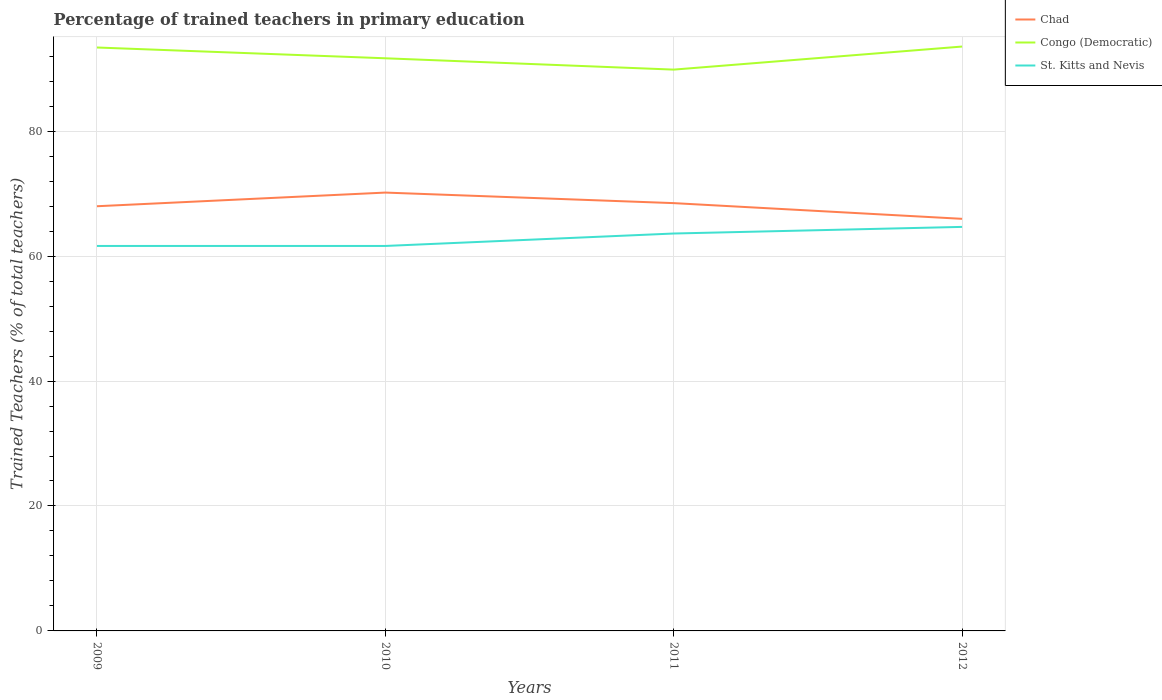How many different coloured lines are there?
Provide a short and direct response. 3. Is the number of lines equal to the number of legend labels?
Make the answer very short. Yes. Across all years, what is the maximum percentage of trained teachers in St. Kitts and Nevis?
Offer a very short reply. 61.63. In which year was the percentage of trained teachers in Chad maximum?
Make the answer very short. 2012. What is the total percentage of trained teachers in Congo (Democratic) in the graph?
Ensure brevity in your answer.  -1.88. What is the difference between the highest and the second highest percentage of trained teachers in Congo (Democratic)?
Your response must be concise. 3.69. Is the percentage of trained teachers in Congo (Democratic) strictly greater than the percentage of trained teachers in St. Kitts and Nevis over the years?
Offer a terse response. No. How many lines are there?
Give a very brief answer. 3. How many years are there in the graph?
Ensure brevity in your answer.  4. What is the difference between two consecutive major ticks on the Y-axis?
Keep it short and to the point. 20. Does the graph contain any zero values?
Offer a terse response. No. Does the graph contain grids?
Offer a very short reply. Yes. How many legend labels are there?
Offer a terse response. 3. How are the legend labels stacked?
Your answer should be compact. Vertical. What is the title of the graph?
Provide a short and direct response. Percentage of trained teachers in primary education. Does "Latvia" appear as one of the legend labels in the graph?
Provide a short and direct response. No. What is the label or title of the X-axis?
Provide a succinct answer. Years. What is the label or title of the Y-axis?
Offer a very short reply. Trained Teachers (% of total teachers). What is the Trained Teachers (% of total teachers) of Chad in 2009?
Your answer should be very brief. 67.98. What is the Trained Teachers (% of total teachers) in Congo (Democratic) in 2009?
Offer a very short reply. 93.39. What is the Trained Teachers (% of total teachers) in St. Kitts and Nevis in 2009?
Your response must be concise. 61.63. What is the Trained Teachers (% of total teachers) in Chad in 2010?
Make the answer very short. 70.17. What is the Trained Teachers (% of total teachers) in Congo (Democratic) in 2010?
Ensure brevity in your answer.  91.67. What is the Trained Teachers (% of total teachers) of St. Kitts and Nevis in 2010?
Your answer should be very brief. 61.63. What is the Trained Teachers (% of total teachers) in Chad in 2011?
Keep it short and to the point. 68.48. What is the Trained Teachers (% of total teachers) in Congo (Democratic) in 2011?
Your response must be concise. 89.85. What is the Trained Teachers (% of total teachers) in St. Kitts and Nevis in 2011?
Provide a succinct answer. 63.62. What is the Trained Teachers (% of total teachers) of Chad in 2012?
Give a very brief answer. 65.97. What is the Trained Teachers (% of total teachers) of Congo (Democratic) in 2012?
Offer a very short reply. 93.55. What is the Trained Teachers (% of total teachers) in St. Kitts and Nevis in 2012?
Give a very brief answer. 64.68. Across all years, what is the maximum Trained Teachers (% of total teachers) in Chad?
Offer a very short reply. 70.17. Across all years, what is the maximum Trained Teachers (% of total teachers) in Congo (Democratic)?
Offer a terse response. 93.55. Across all years, what is the maximum Trained Teachers (% of total teachers) of St. Kitts and Nevis?
Provide a succinct answer. 64.68. Across all years, what is the minimum Trained Teachers (% of total teachers) of Chad?
Provide a succinct answer. 65.97. Across all years, what is the minimum Trained Teachers (% of total teachers) in Congo (Democratic)?
Offer a terse response. 89.85. Across all years, what is the minimum Trained Teachers (% of total teachers) in St. Kitts and Nevis?
Offer a terse response. 61.63. What is the total Trained Teachers (% of total teachers) of Chad in the graph?
Your answer should be compact. 272.6. What is the total Trained Teachers (% of total teachers) in Congo (Democratic) in the graph?
Offer a terse response. 368.46. What is the total Trained Teachers (% of total teachers) in St. Kitts and Nevis in the graph?
Provide a short and direct response. 251.54. What is the difference between the Trained Teachers (% of total teachers) of Chad in 2009 and that in 2010?
Provide a succinct answer. -2.19. What is the difference between the Trained Teachers (% of total teachers) of Congo (Democratic) in 2009 and that in 2010?
Your answer should be compact. 1.73. What is the difference between the Trained Teachers (% of total teachers) of St. Kitts and Nevis in 2009 and that in 2010?
Offer a very short reply. 0. What is the difference between the Trained Teachers (% of total teachers) in Chad in 2009 and that in 2011?
Your answer should be compact. -0.5. What is the difference between the Trained Teachers (% of total teachers) of Congo (Democratic) in 2009 and that in 2011?
Your response must be concise. 3.54. What is the difference between the Trained Teachers (% of total teachers) of St. Kitts and Nevis in 2009 and that in 2011?
Offer a very short reply. -1.99. What is the difference between the Trained Teachers (% of total teachers) in Chad in 2009 and that in 2012?
Your response must be concise. 2.02. What is the difference between the Trained Teachers (% of total teachers) in Congo (Democratic) in 2009 and that in 2012?
Your answer should be very brief. -0.15. What is the difference between the Trained Teachers (% of total teachers) in St. Kitts and Nevis in 2009 and that in 2012?
Your answer should be compact. -3.05. What is the difference between the Trained Teachers (% of total teachers) in Chad in 2010 and that in 2011?
Offer a terse response. 1.69. What is the difference between the Trained Teachers (% of total teachers) of Congo (Democratic) in 2010 and that in 2011?
Your response must be concise. 1.81. What is the difference between the Trained Teachers (% of total teachers) of St. Kitts and Nevis in 2010 and that in 2011?
Your answer should be compact. -1.99. What is the difference between the Trained Teachers (% of total teachers) of Chad in 2010 and that in 2012?
Offer a terse response. 4.2. What is the difference between the Trained Teachers (% of total teachers) in Congo (Democratic) in 2010 and that in 2012?
Offer a terse response. -1.88. What is the difference between the Trained Teachers (% of total teachers) of St. Kitts and Nevis in 2010 and that in 2012?
Your answer should be very brief. -3.05. What is the difference between the Trained Teachers (% of total teachers) in Chad in 2011 and that in 2012?
Your response must be concise. 2.51. What is the difference between the Trained Teachers (% of total teachers) of Congo (Democratic) in 2011 and that in 2012?
Keep it short and to the point. -3.69. What is the difference between the Trained Teachers (% of total teachers) in St. Kitts and Nevis in 2011 and that in 2012?
Your answer should be compact. -1.06. What is the difference between the Trained Teachers (% of total teachers) in Chad in 2009 and the Trained Teachers (% of total teachers) in Congo (Democratic) in 2010?
Your answer should be compact. -23.69. What is the difference between the Trained Teachers (% of total teachers) in Chad in 2009 and the Trained Teachers (% of total teachers) in St. Kitts and Nevis in 2010?
Offer a terse response. 6.36. What is the difference between the Trained Teachers (% of total teachers) of Congo (Democratic) in 2009 and the Trained Teachers (% of total teachers) of St. Kitts and Nevis in 2010?
Your response must be concise. 31.77. What is the difference between the Trained Teachers (% of total teachers) in Chad in 2009 and the Trained Teachers (% of total teachers) in Congo (Democratic) in 2011?
Your response must be concise. -21.87. What is the difference between the Trained Teachers (% of total teachers) of Chad in 2009 and the Trained Teachers (% of total teachers) of St. Kitts and Nevis in 2011?
Offer a very short reply. 4.37. What is the difference between the Trained Teachers (% of total teachers) in Congo (Democratic) in 2009 and the Trained Teachers (% of total teachers) in St. Kitts and Nevis in 2011?
Ensure brevity in your answer.  29.78. What is the difference between the Trained Teachers (% of total teachers) of Chad in 2009 and the Trained Teachers (% of total teachers) of Congo (Democratic) in 2012?
Offer a very short reply. -25.56. What is the difference between the Trained Teachers (% of total teachers) of Chad in 2009 and the Trained Teachers (% of total teachers) of St. Kitts and Nevis in 2012?
Your response must be concise. 3.31. What is the difference between the Trained Teachers (% of total teachers) in Congo (Democratic) in 2009 and the Trained Teachers (% of total teachers) in St. Kitts and Nevis in 2012?
Your answer should be very brief. 28.72. What is the difference between the Trained Teachers (% of total teachers) of Chad in 2010 and the Trained Teachers (% of total teachers) of Congo (Democratic) in 2011?
Give a very brief answer. -19.68. What is the difference between the Trained Teachers (% of total teachers) in Chad in 2010 and the Trained Teachers (% of total teachers) in St. Kitts and Nevis in 2011?
Keep it short and to the point. 6.55. What is the difference between the Trained Teachers (% of total teachers) in Congo (Democratic) in 2010 and the Trained Teachers (% of total teachers) in St. Kitts and Nevis in 2011?
Offer a terse response. 28.05. What is the difference between the Trained Teachers (% of total teachers) of Chad in 2010 and the Trained Teachers (% of total teachers) of Congo (Democratic) in 2012?
Your answer should be compact. -23.38. What is the difference between the Trained Teachers (% of total teachers) in Chad in 2010 and the Trained Teachers (% of total teachers) in St. Kitts and Nevis in 2012?
Keep it short and to the point. 5.49. What is the difference between the Trained Teachers (% of total teachers) of Congo (Democratic) in 2010 and the Trained Teachers (% of total teachers) of St. Kitts and Nevis in 2012?
Offer a very short reply. 26.99. What is the difference between the Trained Teachers (% of total teachers) in Chad in 2011 and the Trained Teachers (% of total teachers) in Congo (Democratic) in 2012?
Your response must be concise. -25.07. What is the difference between the Trained Teachers (% of total teachers) in Chad in 2011 and the Trained Teachers (% of total teachers) in St. Kitts and Nevis in 2012?
Your answer should be compact. 3.81. What is the difference between the Trained Teachers (% of total teachers) in Congo (Democratic) in 2011 and the Trained Teachers (% of total teachers) in St. Kitts and Nevis in 2012?
Keep it short and to the point. 25.18. What is the average Trained Teachers (% of total teachers) in Chad per year?
Offer a very short reply. 68.15. What is the average Trained Teachers (% of total teachers) in Congo (Democratic) per year?
Offer a very short reply. 92.11. What is the average Trained Teachers (% of total teachers) of St. Kitts and Nevis per year?
Ensure brevity in your answer.  62.89. In the year 2009, what is the difference between the Trained Teachers (% of total teachers) of Chad and Trained Teachers (% of total teachers) of Congo (Democratic)?
Make the answer very short. -25.41. In the year 2009, what is the difference between the Trained Teachers (% of total teachers) in Chad and Trained Teachers (% of total teachers) in St. Kitts and Nevis?
Your answer should be compact. 6.36. In the year 2009, what is the difference between the Trained Teachers (% of total teachers) in Congo (Democratic) and Trained Teachers (% of total teachers) in St. Kitts and Nevis?
Make the answer very short. 31.77. In the year 2010, what is the difference between the Trained Teachers (% of total teachers) in Chad and Trained Teachers (% of total teachers) in Congo (Democratic)?
Offer a very short reply. -21.5. In the year 2010, what is the difference between the Trained Teachers (% of total teachers) of Chad and Trained Teachers (% of total teachers) of St. Kitts and Nevis?
Ensure brevity in your answer.  8.54. In the year 2010, what is the difference between the Trained Teachers (% of total teachers) of Congo (Democratic) and Trained Teachers (% of total teachers) of St. Kitts and Nevis?
Your answer should be compact. 30.04. In the year 2011, what is the difference between the Trained Teachers (% of total teachers) in Chad and Trained Teachers (% of total teachers) in Congo (Democratic)?
Keep it short and to the point. -21.37. In the year 2011, what is the difference between the Trained Teachers (% of total teachers) of Chad and Trained Teachers (% of total teachers) of St. Kitts and Nevis?
Ensure brevity in your answer.  4.86. In the year 2011, what is the difference between the Trained Teachers (% of total teachers) of Congo (Democratic) and Trained Teachers (% of total teachers) of St. Kitts and Nevis?
Your response must be concise. 26.24. In the year 2012, what is the difference between the Trained Teachers (% of total teachers) in Chad and Trained Teachers (% of total teachers) in Congo (Democratic)?
Make the answer very short. -27.58. In the year 2012, what is the difference between the Trained Teachers (% of total teachers) in Chad and Trained Teachers (% of total teachers) in St. Kitts and Nevis?
Your answer should be very brief. 1.29. In the year 2012, what is the difference between the Trained Teachers (% of total teachers) in Congo (Democratic) and Trained Teachers (% of total teachers) in St. Kitts and Nevis?
Ensure brevity in your answer.  28.87. What is the ratio of the Trained Teachers (% of total teachers) of Chad in 2009 to that in 2010?
Give a very brief answer. 0.97. What is the ratio of the Trained Teachers (% of total teachers) in Congo (Democratic) in 2009 to that in 2010?
Keep it short and to the point. 1.02. What is the ratio of the Trained Teachers (% of total teachers) in Congo (Democratic) in 2009 to that in 2011?
Your response must be concise. 1.04. What is the ratio of the Trained Teachers (% of total teachers) in St. Kitts and Nevis in 2009 to that in 2011?
Provide a succinct answer. 0.97. What is the ratio of the Trained Teachers (% of total teachers) of Chad in 2009 to that in 2012?
Ensure brevity in your answer.  1.03. What is the ratio of the Trained Teachers (% of total teachers) of Congo (Democratic) in 2009 to that in 2012?
Your response must be concise. 1. What is the ratio of the Trained Teachers (% of total teachers) in St. Kitts and Nevis in 2009 to that in 2012?
Offer a very short reply. 0.95. What is the ratio of the Trained Teachers (% of total teachers) in Chad in 2010 to that in 2011?
Ensure brevity in your answer.  1.02. What is the ratio of the Trained Teachers (% of total teachers) of Congo (Democratic) in 2010 to that in 2011?
Offer a very short reply. 1.02. What is the ratio of the Trained Teachers (% of total teachers) in St. Kitts and Nevis in 2010 to that in 2011?
Offer a terse response. 0.97. What is the ratio of the Trained Teachers (% of total teachers) of Chad in 2010 to that in 2012?
Provide a short and direct response. 1.06. What is the ratio of the Trained Teachers (% of total teachers) of Congo (Democratic) in 2010 to that in 2012?
Your answer should be very brief. 0.98. What is the ratio of the Trained Teachers (% of total teachers) in St. Kitts and Nevis in 2010 to that in 2012?
Your answer should be compact. 0.95. What is the ratio of the Trained Teachers (% of total teachers) of Chad in 2011 to that in 2012?
Offer a very short reply. 1.04. What is the ratio of the Trained Teachers (% of total teachers) in Congo (Democratic) in 2011 to that in 2012?
Your response must be concise. 0.96. What is the ratio of the Trained Teachers (% of total teachers) of St. Kitts and Nevis in 2011 to that in 2012?
Make the answer very short. 0.98. What is the difference between the highest and the second highest Trained Teachers (% of total teachers) in Chad?
Provide a short and direct response. 1.69. What is the difference between the highest and the second highest Trained Teachers (% of total teachers) of Congo (Democratic)?
Keep it short and to the point. 0.15. What is the difference between the highest and the second highest Trained Teachers (% of total teachers) of St. Kitts and Nevis?
Provide a succinct answer. 1.06. What is the difference between the highest and the lowest Trained Teachers (% of total teachers) in Chad?
Ensure brevity in your answer.  4.2. What is the difference between the highest and the lowest Trained Teachers (% of total teachers) of Congo (Democratic)?
Keep it short and to the point. 3.69. What is the difference between the highest and the lowest Trained Teachers (% of total teachers) in St. Kitts and Nevis?
Ensure brevity in your answer.  3.05. 